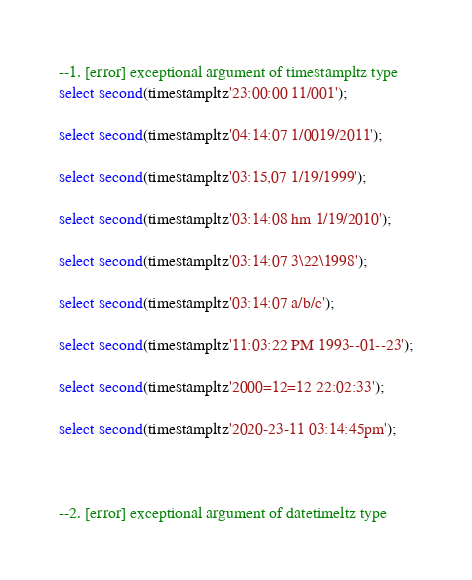Convert code to text. <code><loc_0><loc_0><loc_500><loc_500><_SQL_>
--1. [error] exceptional argument of timestampltz type
select second(timestampltz'23:00:00 11/001');

select second(timestampltz'04:14:07 1/0019/2011');

select second(timestampltz'03:15,07 1/19/1999');

select second(timestampltz'03:14:08 hm 1/19/2010');

select second(timestampltz'03:14:07 3\22\1998');

select second(timestampltz'03:14:07 a/b/c');

select second(timestampltz'11:03:22 PM 1993--01--23');

select second(timestampltz'2000=12=12 22:02:33');

select second(timestampltz'2020-23-11 03:14:45pm');



--2. [error] exceptional argument of datetimeltz type</code> 